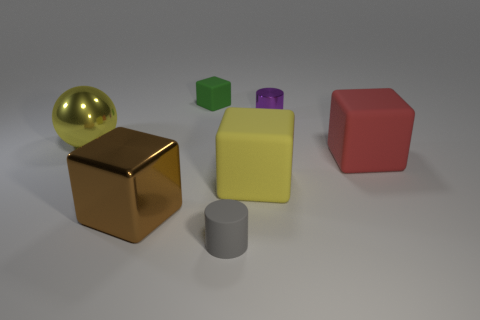How many matte things are either tiny yellow cubes or big balls?
Your answer should be compact. 0. The matte thing in front of the big brown object is what color?
Provide a short and direct response. Gray. What shape is the yellow metallic object that is the same size as the red block?
Ensure brevity in your answer.  Sphere. There is a tiny rubber cylinder; does it have the same color as the rubber thing that is behind the big yellow shiny ball?
Provide a short and direct response. No. What number of objects are large rubber objects that are on the left side of the tiny purple metal object or small cylinders that are behind the big brown shiny cube?
Your answer should be very brief. 2. There is a sphere that is the same size as the shiny block; what is it made of?
Your response must be concise. Metal. What number of other objects are the same material as the sphere?
Your answer should be very brief. 2. There is a tiny rubber thing in front of the small metallic object; is its shape the same as the metallic object in front of the red cube?
Provide a short and direct response. No. There is a tiny matte thing that is behind the metallic object on the left side of the block that is on the left side of the small rubber block; what color is it?
Your response must be concise. Green. What number of other things are there of the same color as the sphere?
Offer a terse response. 1. 